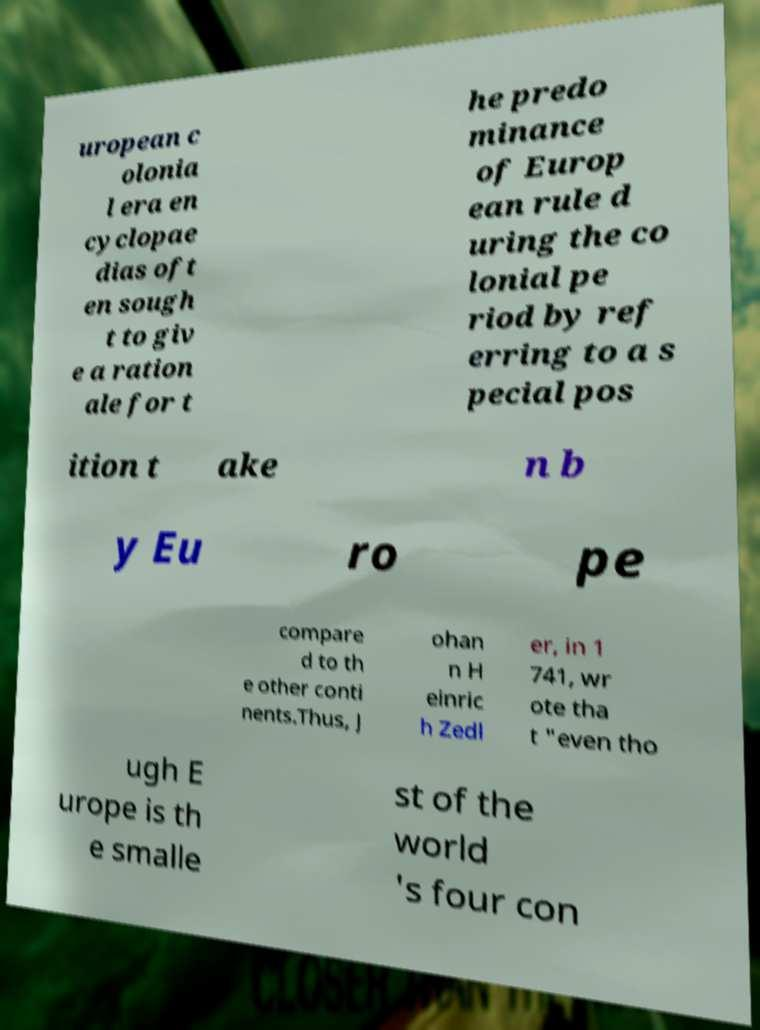Please read and relay the text visible in this image. What does it say? uropean c olonia l era en cyclopae dias oft en sough t to giv e a ration ale for t he predo minance of Europ ean rule d uring the co lonial pe riod by ref erring to a s pecial pos ition t ake n b y Eu ro pe compare d to th e other conti nents.Thus, J ohan n H einric h Zedl er, in 1 741, wr ote tha t "even tho ugh E urope is th e smalle st of the world 's four con 